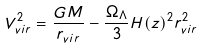<formula> <loc_0><loc_0><loc_500><loc_500>V _ { v i r } ^ { 2 } = \frac { G M } { r _ { v i r } } - \frac { \Omega _ { \Lambda } } { 3 } H ( z ) ^ { 2 } r _ { v i r } ^ { 2 }</formula> 